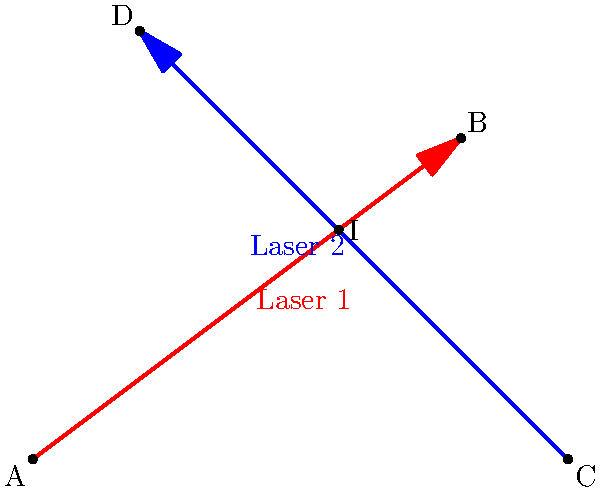In the classic game Venom, two laser beams are fired from different positions in a 2D space. Laser 1 is fired from point A(0, 0) towards point B(8, 6), while Laser 2 is fired from point C(10, 0) towards point D(2, 8). At what point (x, y) do these laser beams intersect? To find the intersection point of the two laser beams, we need to use the concept of line equations and solve them simultaneously. Let's approach this step-by-step:

1) First, let's find the equations of both lines:

   For Laser 1 (Line AB):
   Slope $m_1 = \frac{6-0}{8-0} = \frac{3}{4}$
   Equation: $y = \frac{3}{4}x$

   For Laser 2 (Line CD):
   Slope $m_2 = \frac{8-0}{2-10} = -1$
   Equation: $y = -x + 10$

2) At the intersection point, the x and y coordinates will be the same for both lines. So, we can equate the two y expressions:

   $\frac{3}{4}x = -x + 10$

3) Solve for x:
   $\frac{3}{4}x + x = 10$
   $\frac{7}{4}x = 10$
   $x = \frac{40}{7} \approx 5.71$

4) Substitute this x value back into either of the original equations to find y. Let's use the equation of Laser 1:

   $y = \frac{3}{4}(\frac{40}{7}) = \frac{120}{28} = \frac{30}{7} \approx 4.29$

Therefore, the laser beams intersect at the point $(\frac{40}{7}, \frac{30}{7})$ or approximately (5.71, 4.29).
Answer: $(\frac{40}{7}, \frac{30}{7})$ 